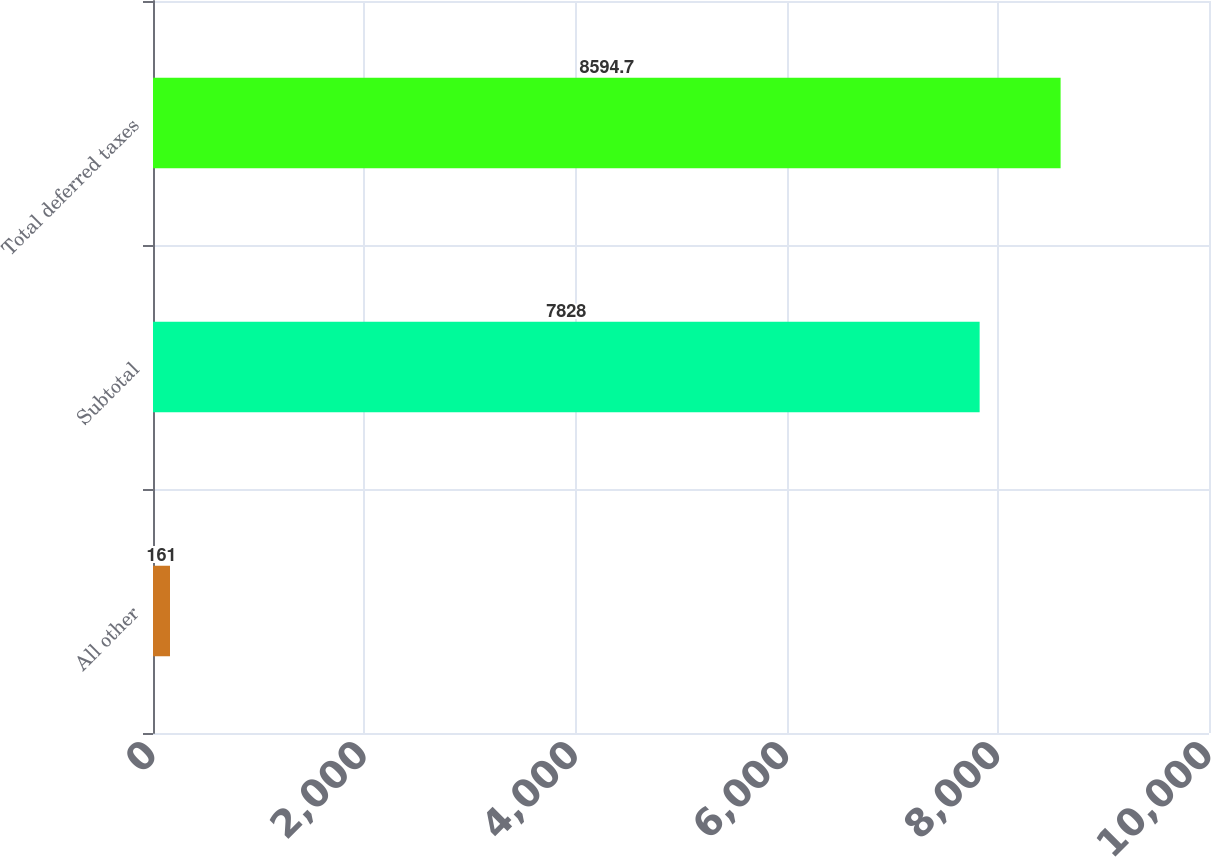Convert chart to OTSL. <chart><loc_0><loc_0><loc_500><loc_500><bar_chart><fcel>All other<fcel>Subtotal<fcel>Total deferred taxes<nl><fcel>161<fcel>7828<fcel>8594.7<nl></chart> 